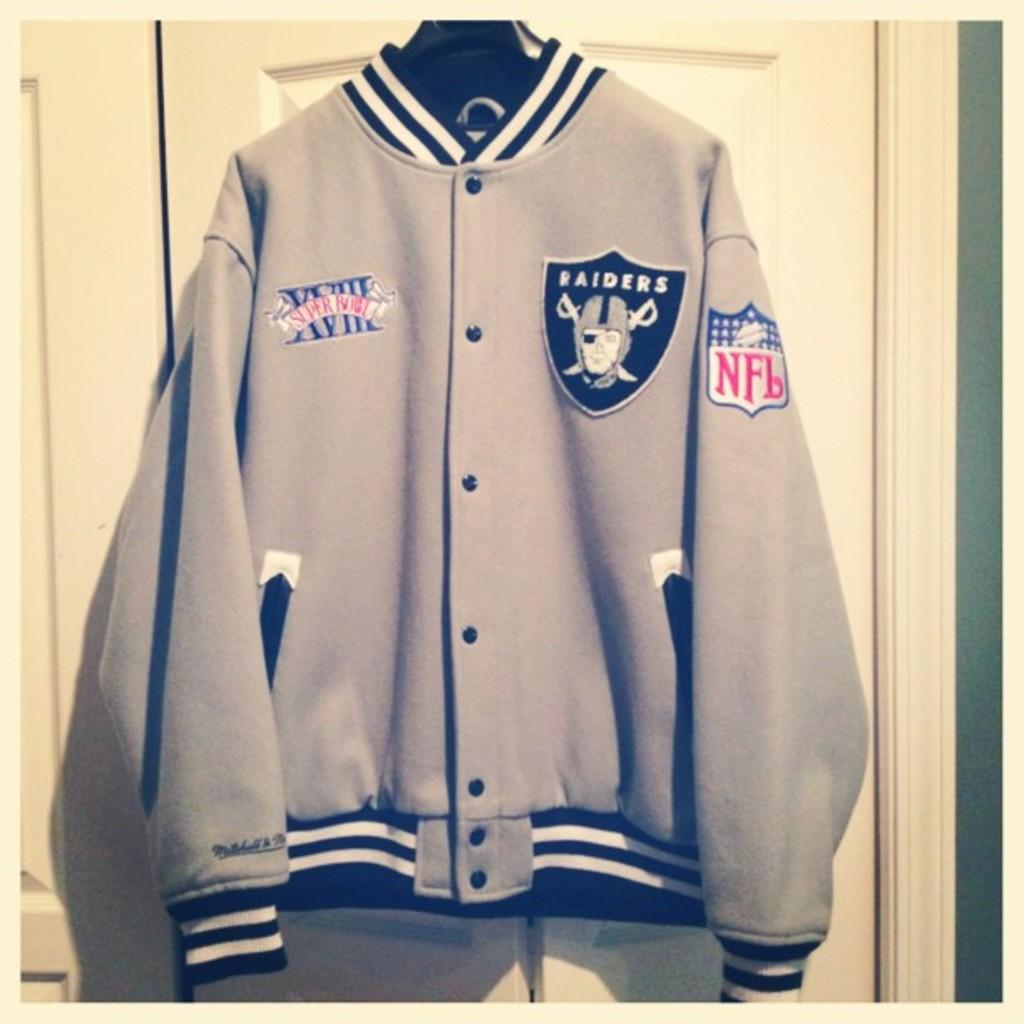<image>
Describe the image concisely. Gray jacket with a logo that says RAIDERS on it. 